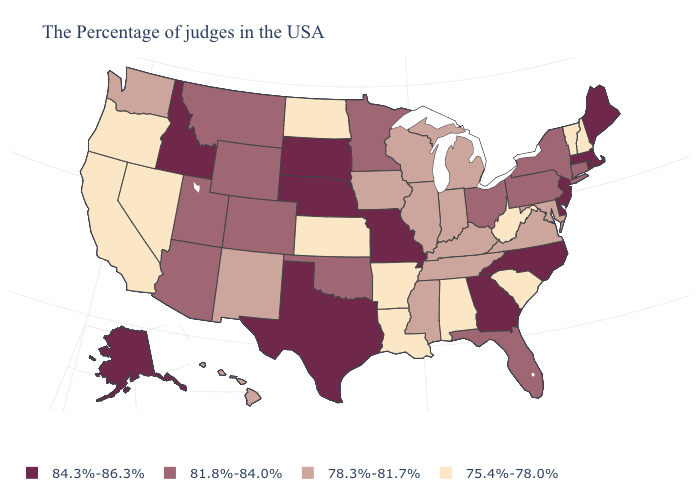Does Alaska have the same value as Georgia?
Write a very short answer. Yes. What is the value of New York?
Answer briefly. 81.8%-84.0%. Name the states that have a value in the range 84.3%-86.3%?
Quick response, please. Maine, Massachusetts, Rhode Island, New Jersey, Delaware, North Carolina, Georgia, Missouri, Nebraska, Texas, South Dakota, Idaho, Alaska. What is the value of South Carolina?
Answer briefly. 75.4%-78.0%. Among the states that border Delaware , does Maryland have the highest value?
Write a very short answer. No. Among the states that border Connecticut , does New York have the lowest value?
Write a very short answer. Yes. Does Wyoming have the same value as Missouri?
Short answer required. No. Does Nebraska have a higher value than Iowa?
Keep it brief. Yes. Is the legend a continuous bar?
Answer briefly. No. What is the value of Illinois?
Short answer required. 78.3%-81.7%. Does the map have missing data?
Be succinct. No. What is the value of Maryland?
Answer briefly. 78.3%-81.7%. Name the states that have a value in the range 81.8%-84.0%?
Concise answer only. Connecticut, New York, Pennsylvania, Ohio, Florida, Minnesota, Oklahoma, Wyoming, Colorado, Utah, Montana, Arizona. Does the map have missing data?
Concise answer only. No. What is the lowest value in the Northeast?
Answer briefly. 75.4%-78.0%. 